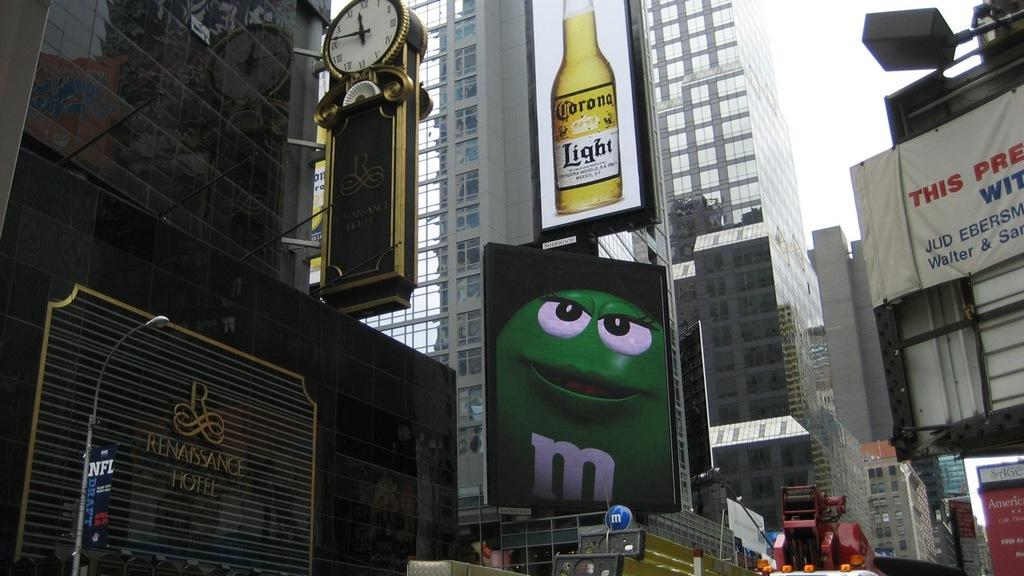<image>
Relay a brief, clear account of the picture shown. An outside photo of the Renaissance hotel, taken just before noon. 